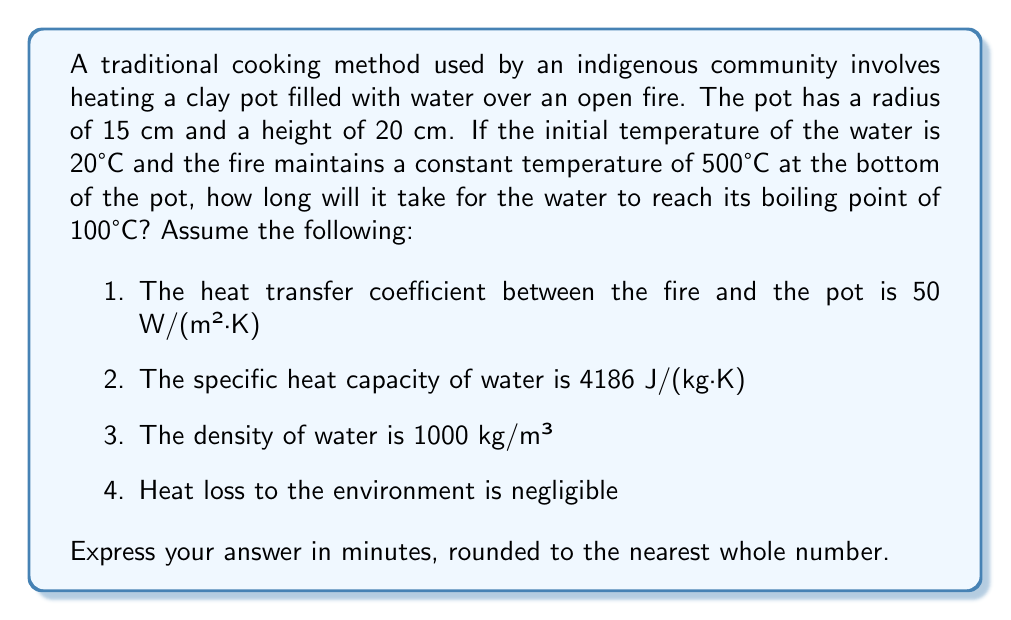Teach me how to tackle this problem. To solve this problem, we'll use the heat transfer equation and follow these steps:

1. Calculate the volume of water in the pot:
   $$V = \pi r^2 h = \pi \cdot (0.15 \text{ m})^2 \cdot 0.20 \text{ m} = 0.014137 \text{ m}^3$$

2. Calculate the mass of water:
   $$m = \rho V = 1000 \text{ kg/m}^3 \cdot 0.014137 \text{ m}^3 = 14.137 \text{ kg}$$

3. Calculate the area of the bottom of the pot:
   $$A = \pi r^2 = \pi \cdot (0.15 \text{ m})^2 = 0.07069 \text{ m}^2$$

4. Calculate the temperature difference:
   $$\Delta T = T_{\text{fire}} - T_{\text{water}} = 500°\text{C} - 20°\text{C} = 480°\text{C}$$

5. Use the heat transfer equation to find the rate of heat transfer:
   $$Q = hA\Delta T = 50 \text{ W/(m}^2\text{·K)} \cdot 0.07069 \text{ m}^2 \cdot 480 \text{ K} = 1696.56 \text{ W}$$

6. Calculate the energy required to heat the water to boiling point:
   $$E = mc\Delta T = 14.137 \text{ kg} \cdot 4186 \text{ J/(kg·K)} \cdot (100°\text{C} - 20°\text{C}) = 4737592 \text{ J}$$

7. Calculate the time required:
   $$t = \frac{E}{Q} = \frac{4737592 \text{ J}}{1696.56 \text{ W}} = 2792.45 \text{ s}$$

8. Convert seconds to minutes and round to the nearest whole number:
   $$t_{\text{minutes}} = \frac{2792.45 \text{ s}}{60 \text{ s/min}} \approx 47 \text{ minutes}$$
Answer: 47 minutes 